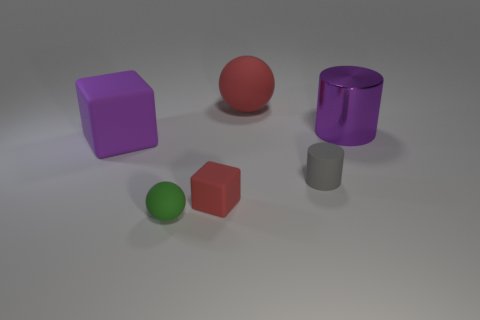Are there fewer large rubber objects that are in front of the large purple matte block than tiny matte objects right of the tiny gray matte object?
Keep it short and to the point. No. The other thing that is the same shape as the small gray rubber thing is what color?
Give a very brief answer. Purple. There is a big red matte object; is its shape the same as the tiny green thing that is on the left side of the purple cylinder?
Provide a succinct answer. Yes. What number of objects are small rubber objects that are right of the tiny red object or large objects behind the big cylinder?
Ensure brevity in your answer.  2. What is the material of the large red sphere?
Make the answer very short. Rubber. How many other things are there of the same size as the red rubber ball?
Offer a terse response. 2. There is a matte sphere that is behind the purple block; how big is it?
Your response must be concise. Large. There is a large cylinder to the right of the rubber block that is on the right side of the large purple object in front of the metallic thing; what is it made of?
Your response must be concise. Metal. Is the shape of the purple metallic object the same as the small gray matte object?
Your answer should be compact. Yes. How many rubber objects are small gray cylinders or tiny cubes?
Provide a succinct answer. 2. 